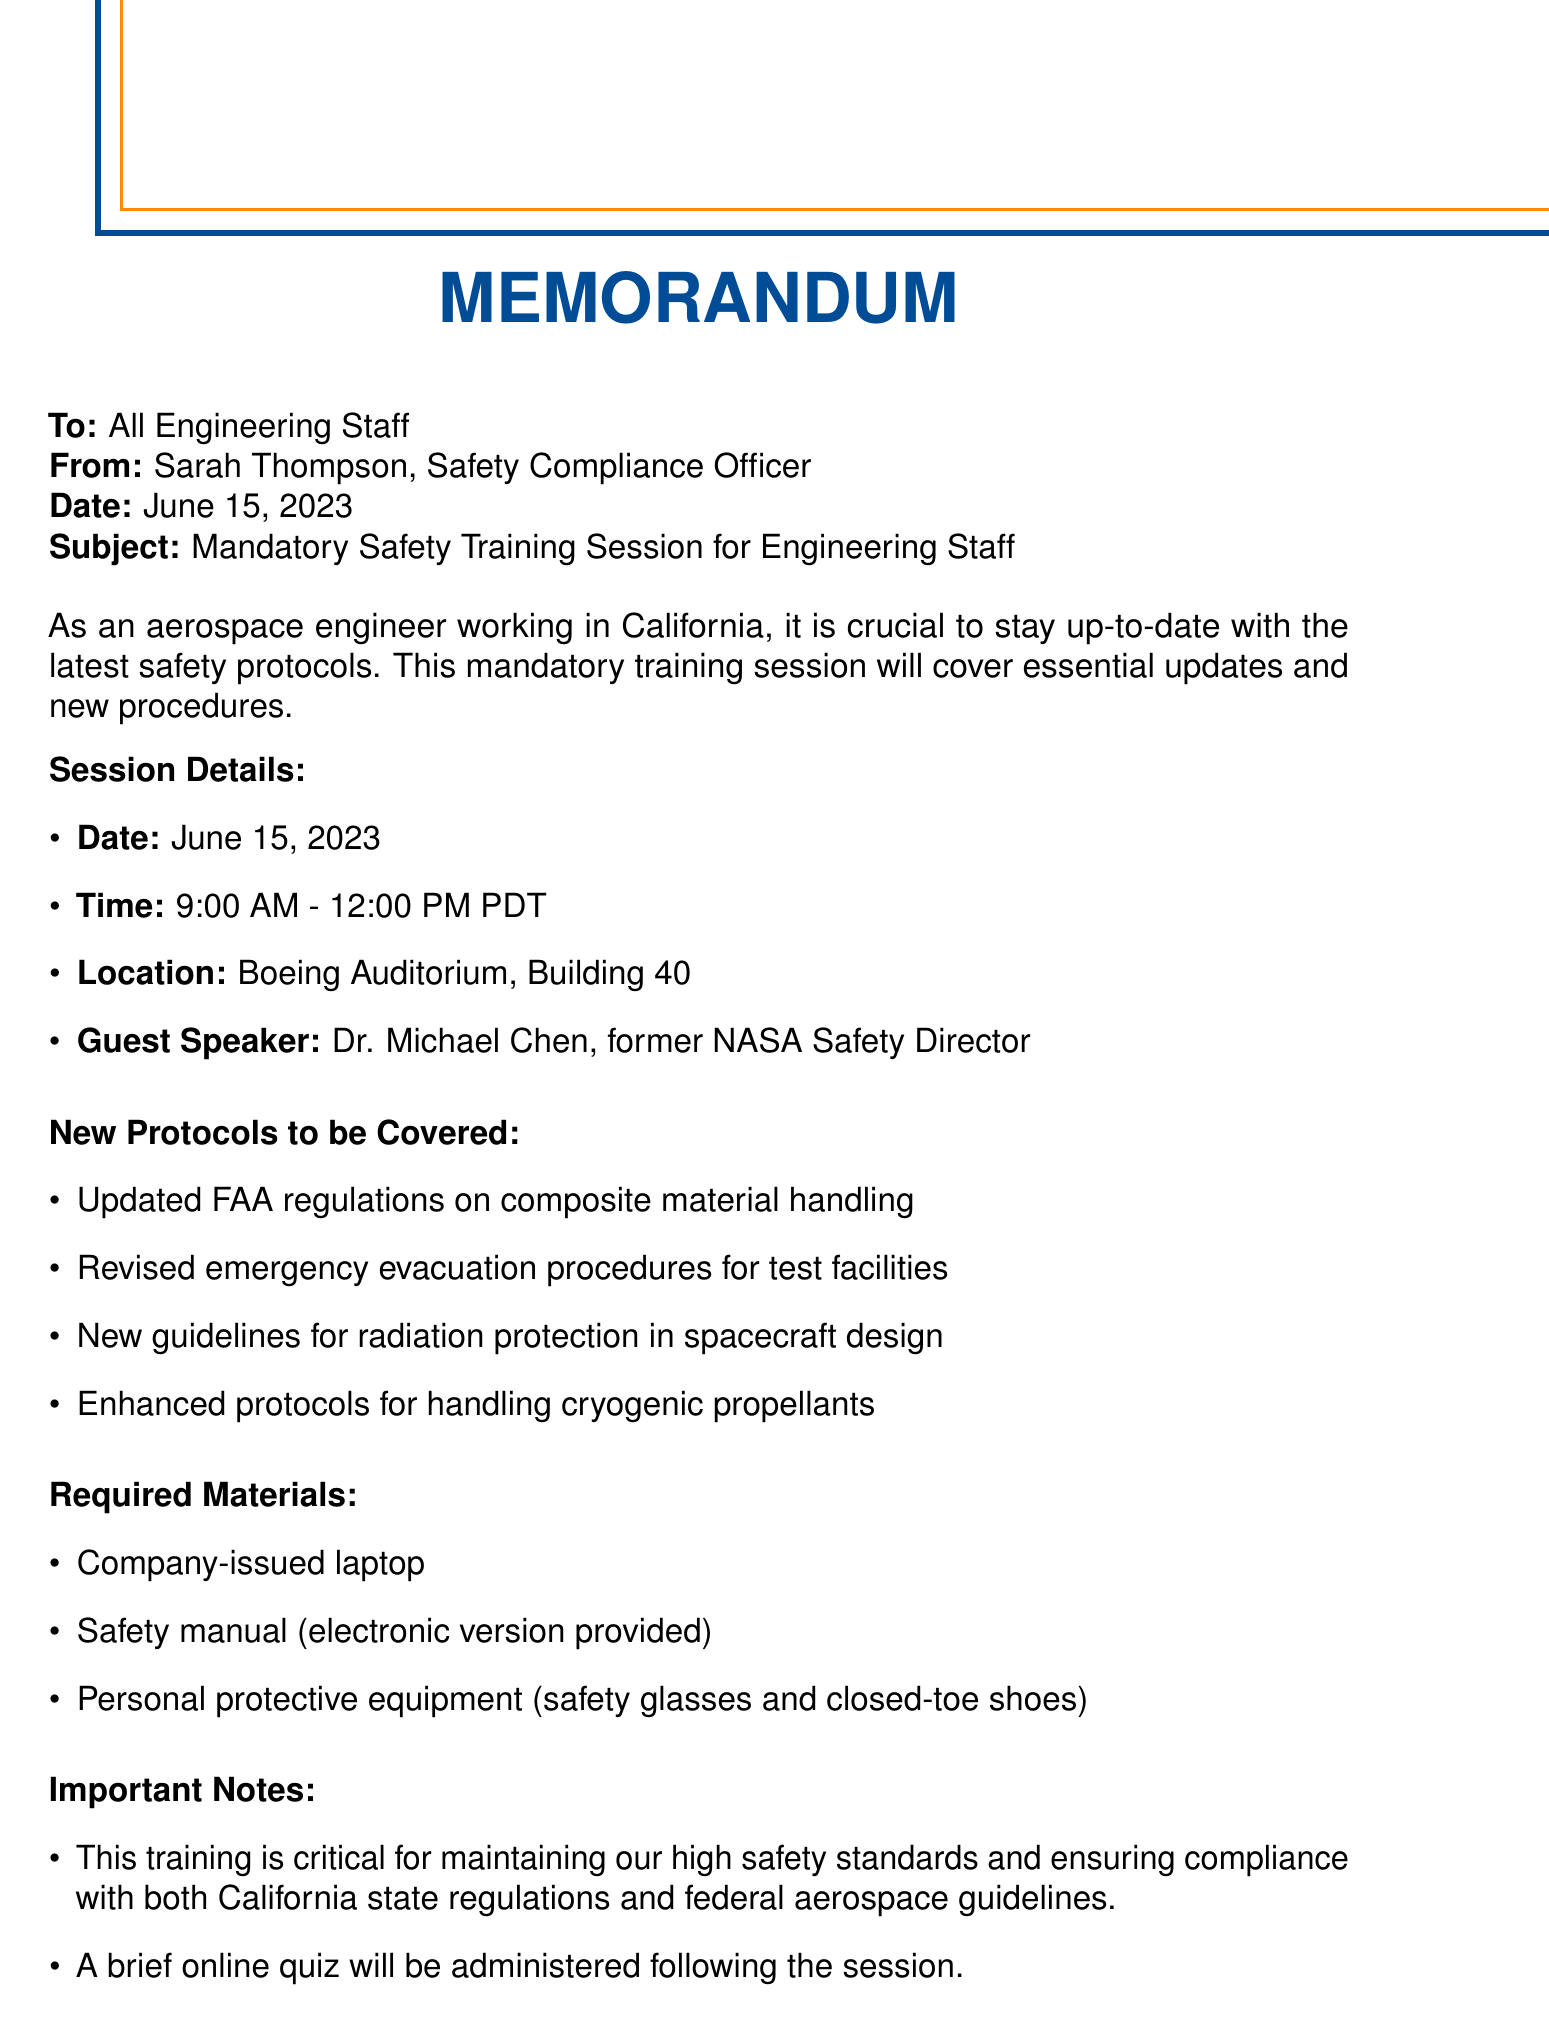What is the date of the training session? The date of the training session is explicitly mentioned in the document as June 15, 2023.
Answer: June 15, 2023 What are the training session hours? The hours of the training session are detailed in the document as 9:00 AM - 12:00 PM PDT.
Answer: 9:00 AM - 12:00 PM PDT Who is the guest speaker for the session? The guest speaker's name is specified in the document as Dr. Michael Chen.
Answer: Dr. Michael Chen What location is designated for the training session? The location is indicated in the document, where it states the session will be held at Boeing Auditorium, Building 40.
Answer: Boeing Auditorium, Building 40 What new protocol relates to handling materials? The document lists several new protocols; one specifically mentions "Updated FAA regulations on composite material handling."
Answer: Updated FAA regulations on composite material handling Why is this training considered critical? The document states that the training is critical for maintaining high safety standards and regulatory compliance.
Answer: High safety standards and compliance What is required to attend the training? The required material for the training is listed in the document, including a company-issued laptop and safety manual.
Answer: Company-issued laptop How long is the certification valid after training? The duration for which the certification is valid is mentioned in the document as two years.
Answer: Two years What will happen after the training session? The document indicates that a brief online quiz will be administered following the session.
Answer: A brief online quiz Where should attendees park? The parking information provided in the document specifies to use Lot C, adjacent to Building 40.
Answer: Lot C 